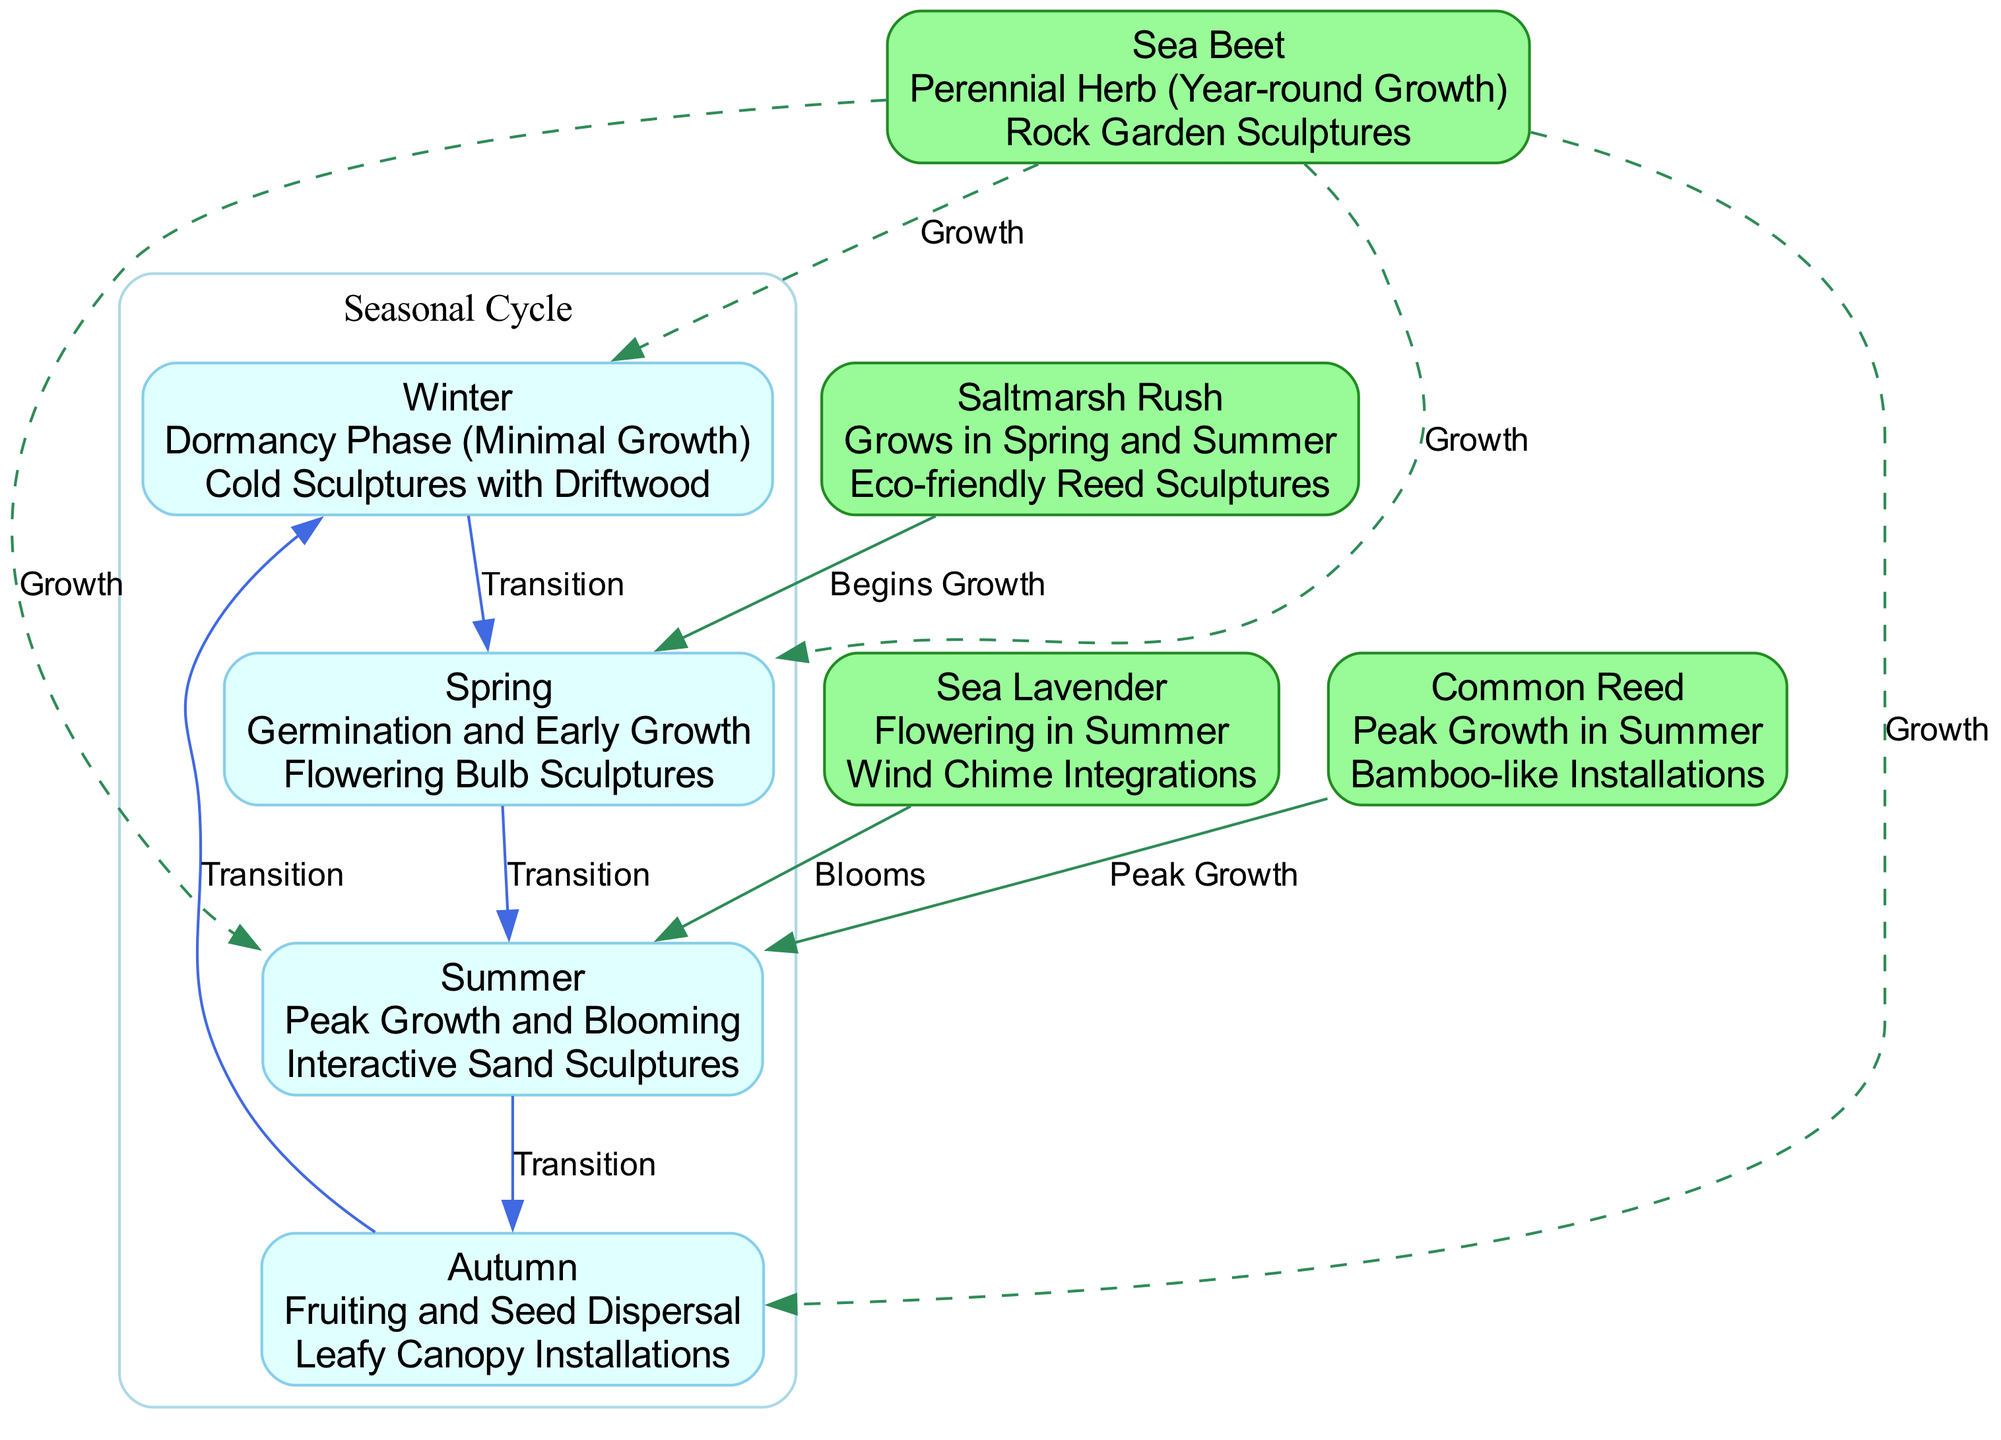What is the interaction associated with winter? In the diagram, the winter node specifically lists its artistic interaction as "Cold Sculptures with Driftwood." Thus, this is the answer to the interaction associated with the winter season.
Answer: Cold Sculptures with Driftwood What is the primary activity of Sea Beet? The Sea Beet node indicates that it is a "Perennial Herb (Year-round Growth)," which describes its primary activity throughout the year.
Answer: Year-round Growth How many seasons are represented in the diagram? The diagram includes four seasonal nodes: Winter, Spring, Summer, and Autumn. Therefore, by counting these nodes, the answer is four.
Answer: Four Which plant blooms in summer? According to the diagram, the Sea Lavender node has a specific connection labeled "Blooms" to the summer node. This indicates that Sea Lavender is the plant that blooms in summer.
Answer: Sea Lavender What transitions from autumn to winter? In the diagram, the edge connecting the autumn node to the winter node is labeled "Transition." This implies that there is a transition from autumn to winter.
Answer: Autumn What is the artistic interaction during peak growth for Common Reed? The diagram shows that during peak growth in summer, the Common Reed's artistic interaction is "Bamboo-like Installations." This corresponds directly to the artistic element associated with its peak growth.
Answer: Bamboo-like Installations Which plant begins growth in spring? The Saltmarsh Rush node is indicated to have starts its growth in spring as noted in the diagram with a connection labeled "Begins Growth." Thus, the answer is the Saltmarsh Rush.
Answer: Saltmarsh Rush Which season follows spring? The edge labeled "Transition" that goes from spring to summer indicates that summer directly follows spring in the seasonal cycle depicted in the diagram.
Answer: Summer 